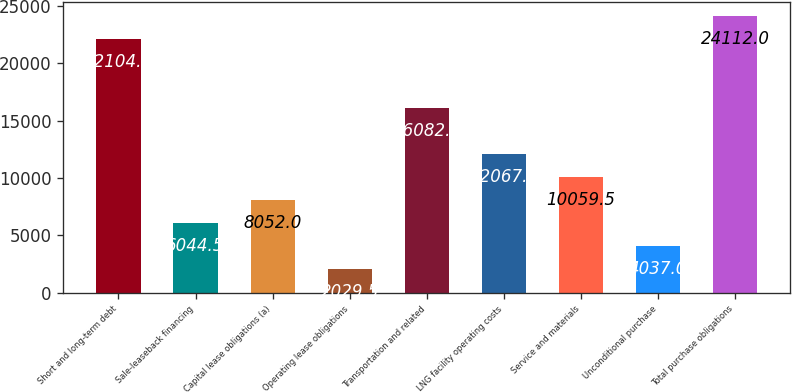Convert chart. <chart><loc_0><loc_0><loc_500><loc_500><bar_chart><fcel>Short and long-term debt<fcel>Sale-leaseback financing<fcel>Capital lease obligations (a)<fcel>Operating lease obligations<fcel>Transportation and related<fcel>LNG facility operating costs<fcel>Service and materials<fcel>Unconditional purchase<fcel>Total purchase obligations<nl><fcel>22104.5<fcel>6044.5<fcel>8052<fcel>2029.5<fcel>16082<fcel>12067<fcel>10059.5<fcel>4037<fcel>24112<nl></chart> 